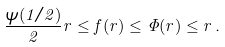<formula> <loc_0><loc_0><loc_500><loc_500>\frac { \psi ( 1 / 2 ) } { 2 } r \leq f ( r ) \leq \Phi ( r ) \leq r \, .</formula> 